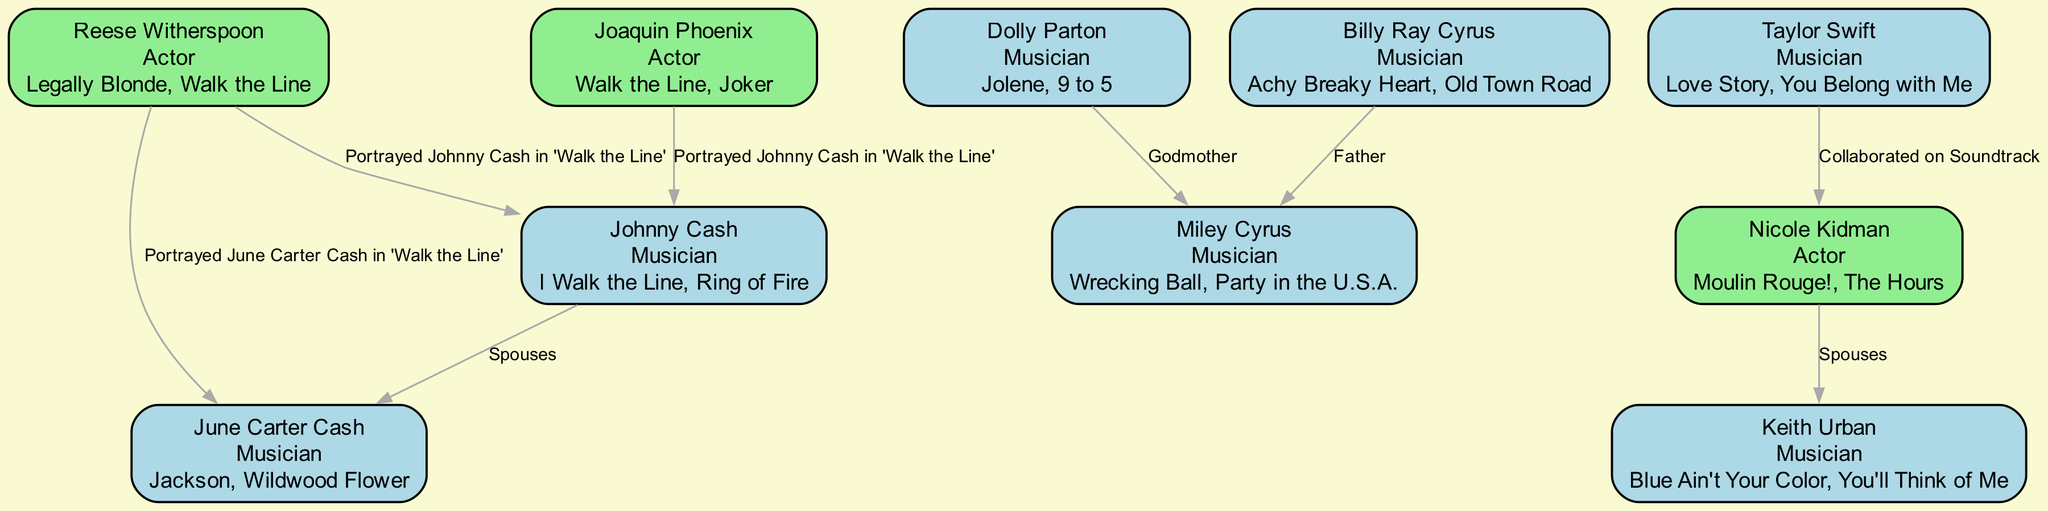What is Johnny Cash's profession? The diagram includes nodes that list the professions of each individual. For Johnny Cash, the node specifies that his profession is "Musician."
Answer: Musician Who portrayed June Carter Cash in 'Walk the Line'? The connections between the nodes indicate various portrayals. From the node connecting Reese Witherspoon to June Carter Cash, we see that she portrayed June in the film.
Answer: Reese Witherspoon How many notable works does Dolly Parton have listed? The node for Dolly Parton shows two notable works: "Jolene" and "9 to 5." By counting the items in the 'notableWorks' list, we determine that she has two noted works.
Answer: 2 What is the relationship between Nicole Kidman and Keith Urban? The diagram shows a direct connection between Nicole Kidman and Keith Urban, labeled as "Spouses." This implies that they are married to each other.
Answer: Spouses Who is Miley Cyrus's father according to the diagram? By examining the connections, the node for Billy Ray Cyrus is linked to Miley Cyrus and is labeled as "Father," indicating he is her father.
Answer: Billy Ray Cyrus How many musicians are represented in the diagram? Counting the nodes indicating musicians: Johnny Cash, June Carter Cash, Dolly Parton, Miley Cyrus, Billy Ray Cyrus, Taylor Swift, and Keith Urban, which totals seven musicians.
Answer: 7 Which two actors portrayed Johnny Cash in 'Walk the Line'? The connections demonstrate that both Reese Witherspoon and Joaquin Phoenix portrayed Johnny Cash in the film. Thus, they are the two actors associated with this role.
Answer: Reese Witherspoon, Joaquin Phoenix What notable work connects Taylor Swift and Nicole Kidman? The diagram illustrates a collaboration connection labeled "Collaborated on Soundtrack" between Taylor Swift and Nicole Kidman, indicating they worked together on a soundtrack project.
Answer: Collaborated on Soundtrack What relationship connects June Carter Cash and Johnny Cash? The link between June Carter Cash and Johnny Cash is described as "Spouses," establishing that they were married.
Answer: Spouses 